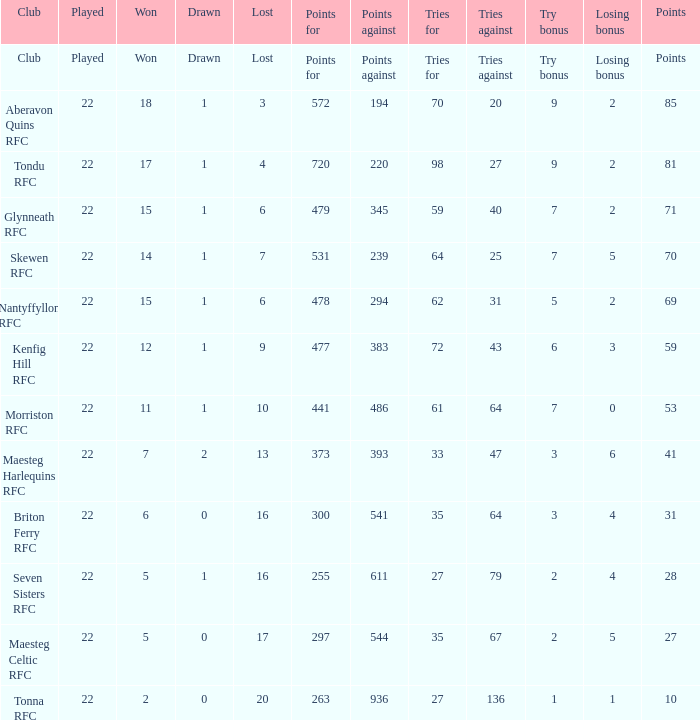How many tries against got the club with 62 tries for? 31.0. 